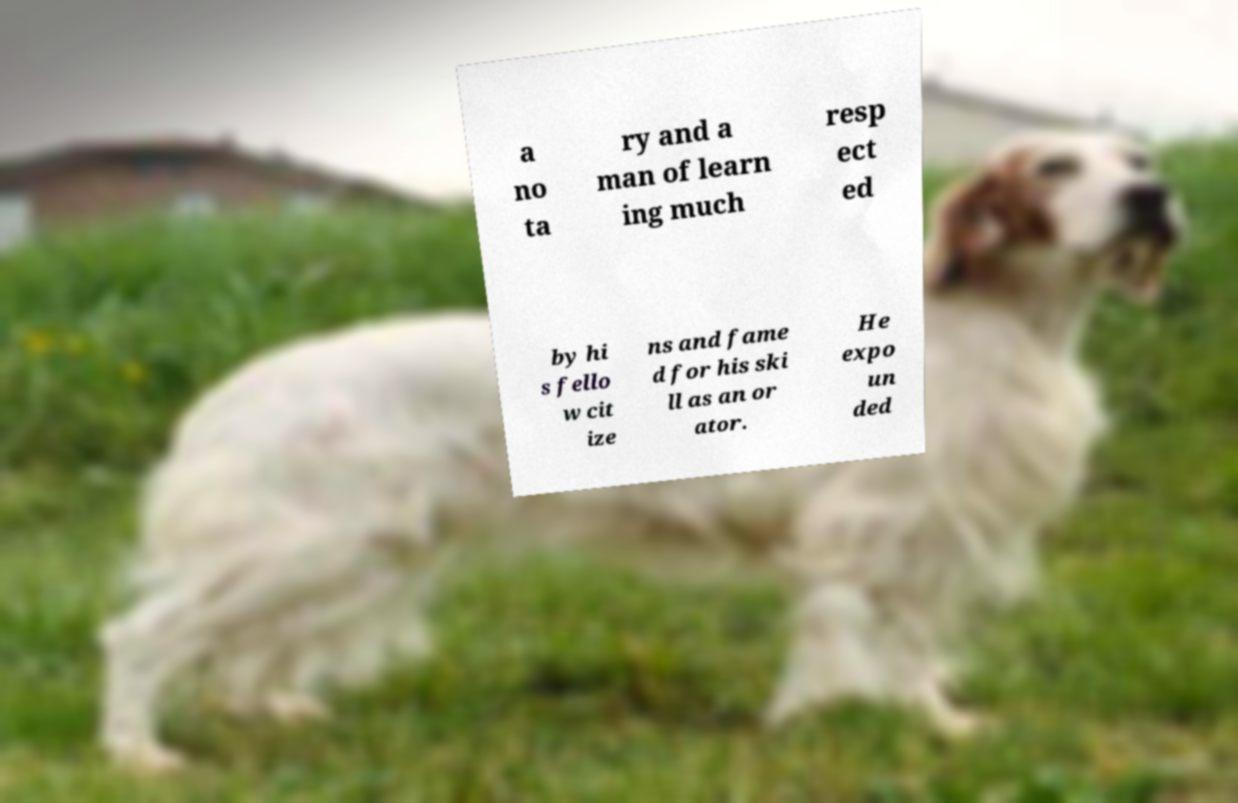Please identify and transcribe the text found in this image. a no ta ry and a man of learn ing much resp ect ed by hi s fello w cit ize ns and fame d for his ski ll as an or ator. He expo un ded 